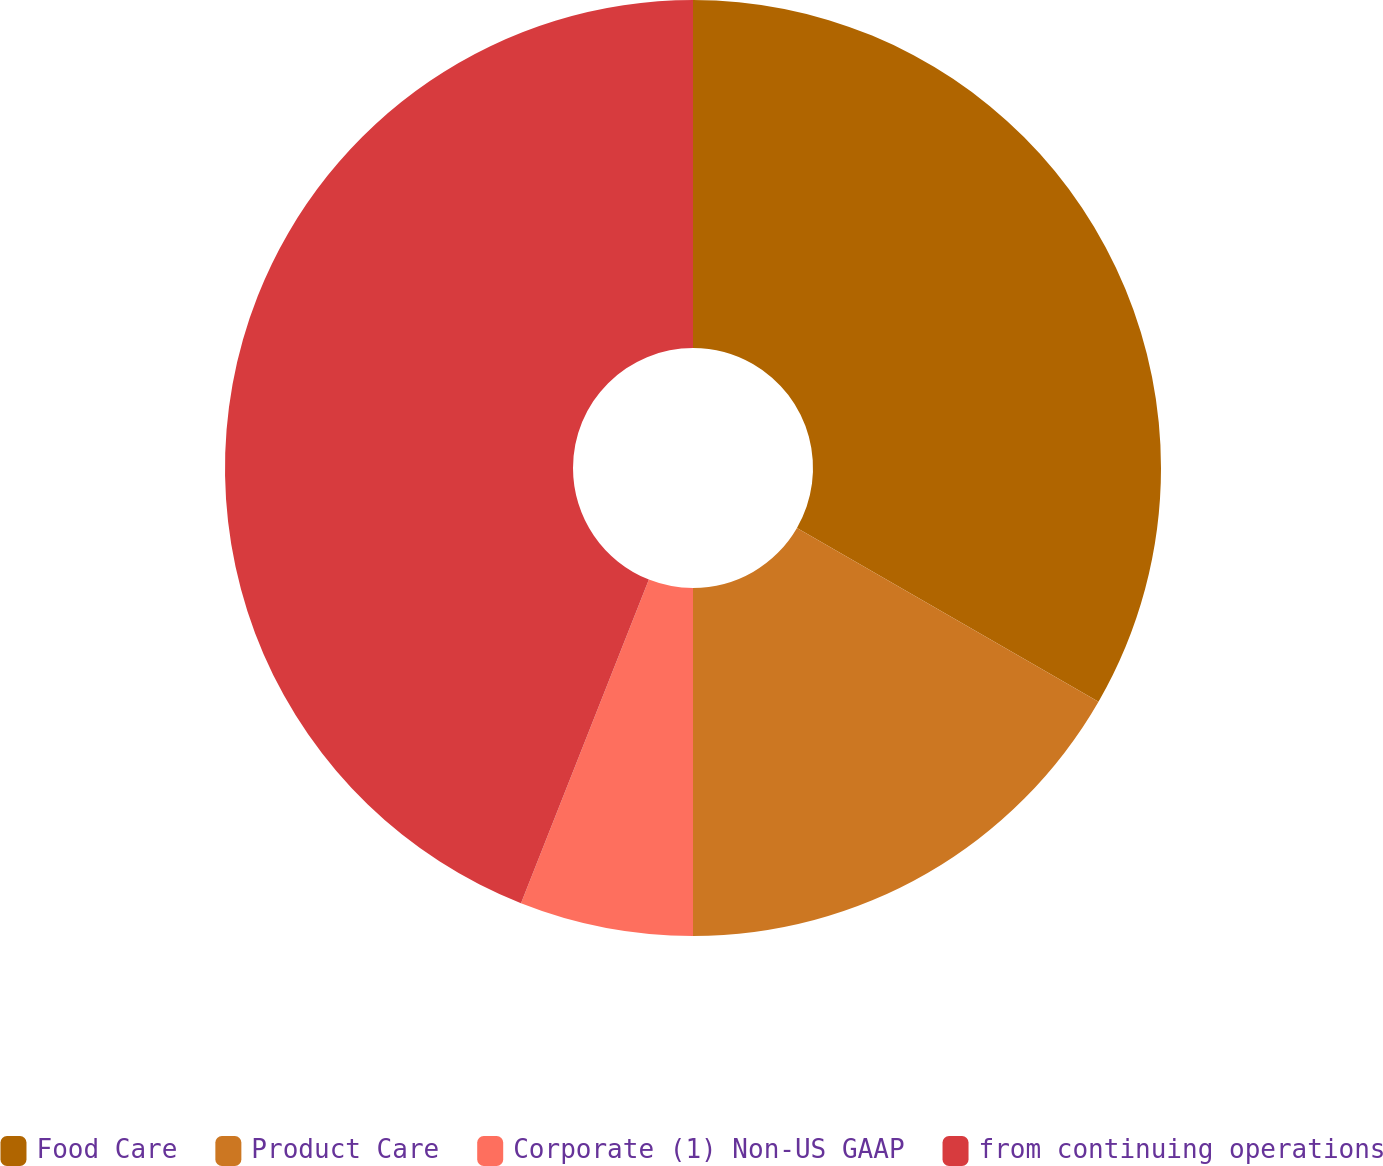Convert chart. <chart><loc_0><loc_0><loc_500><loc_500><pie_chart><fcel>Food Care<fcel>Product Care<fcel>Corporate (1) Non-US GAAP<fcel>from continuing operations<nl><fcel>33.32%<fcel>16.68%<fcel>5.99%<fcel>44.01%<nl></chart> 